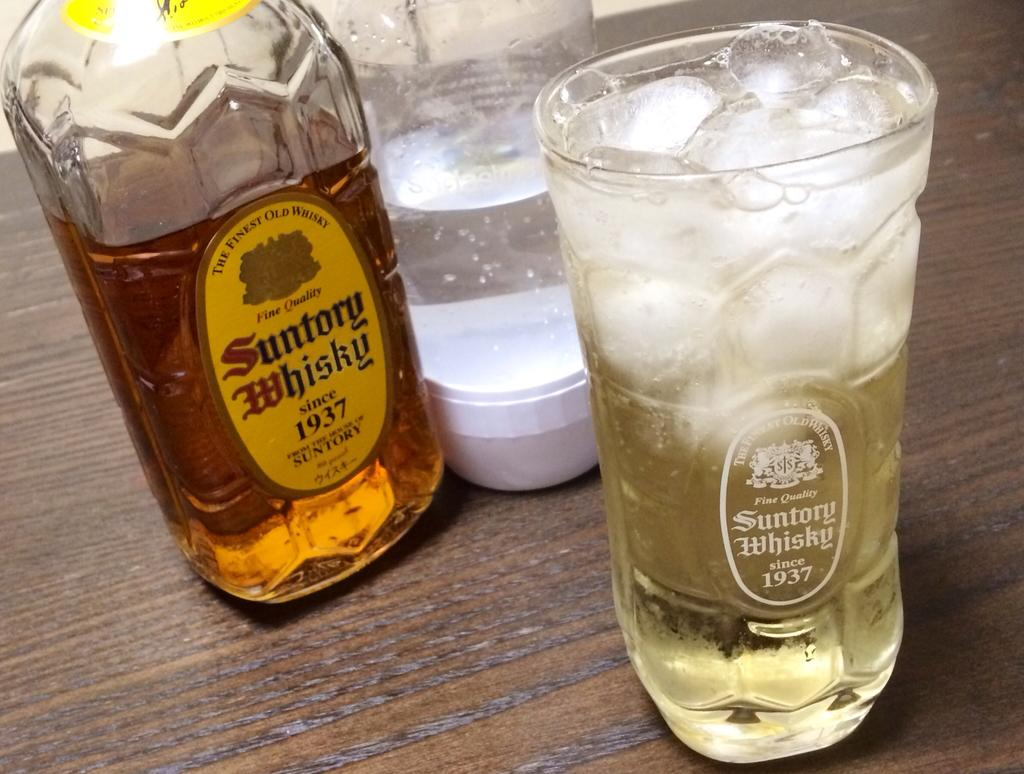<image>
Write a terse but informative summary of the picture. a full glass and bottle of Suntory Whiskey on a wood table 